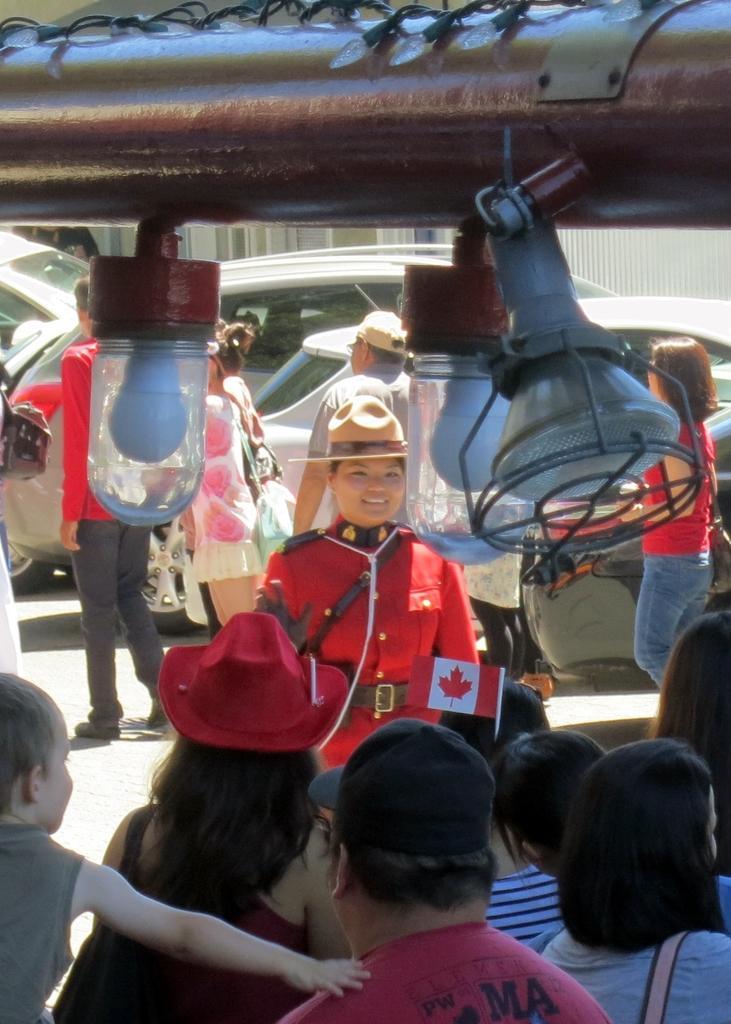Can you describe this image briefly? Bottom of the image few people are standing and watching. Behind them there are some vehicles. Top of the image there is a pipe, on the pipe there are some lights. 